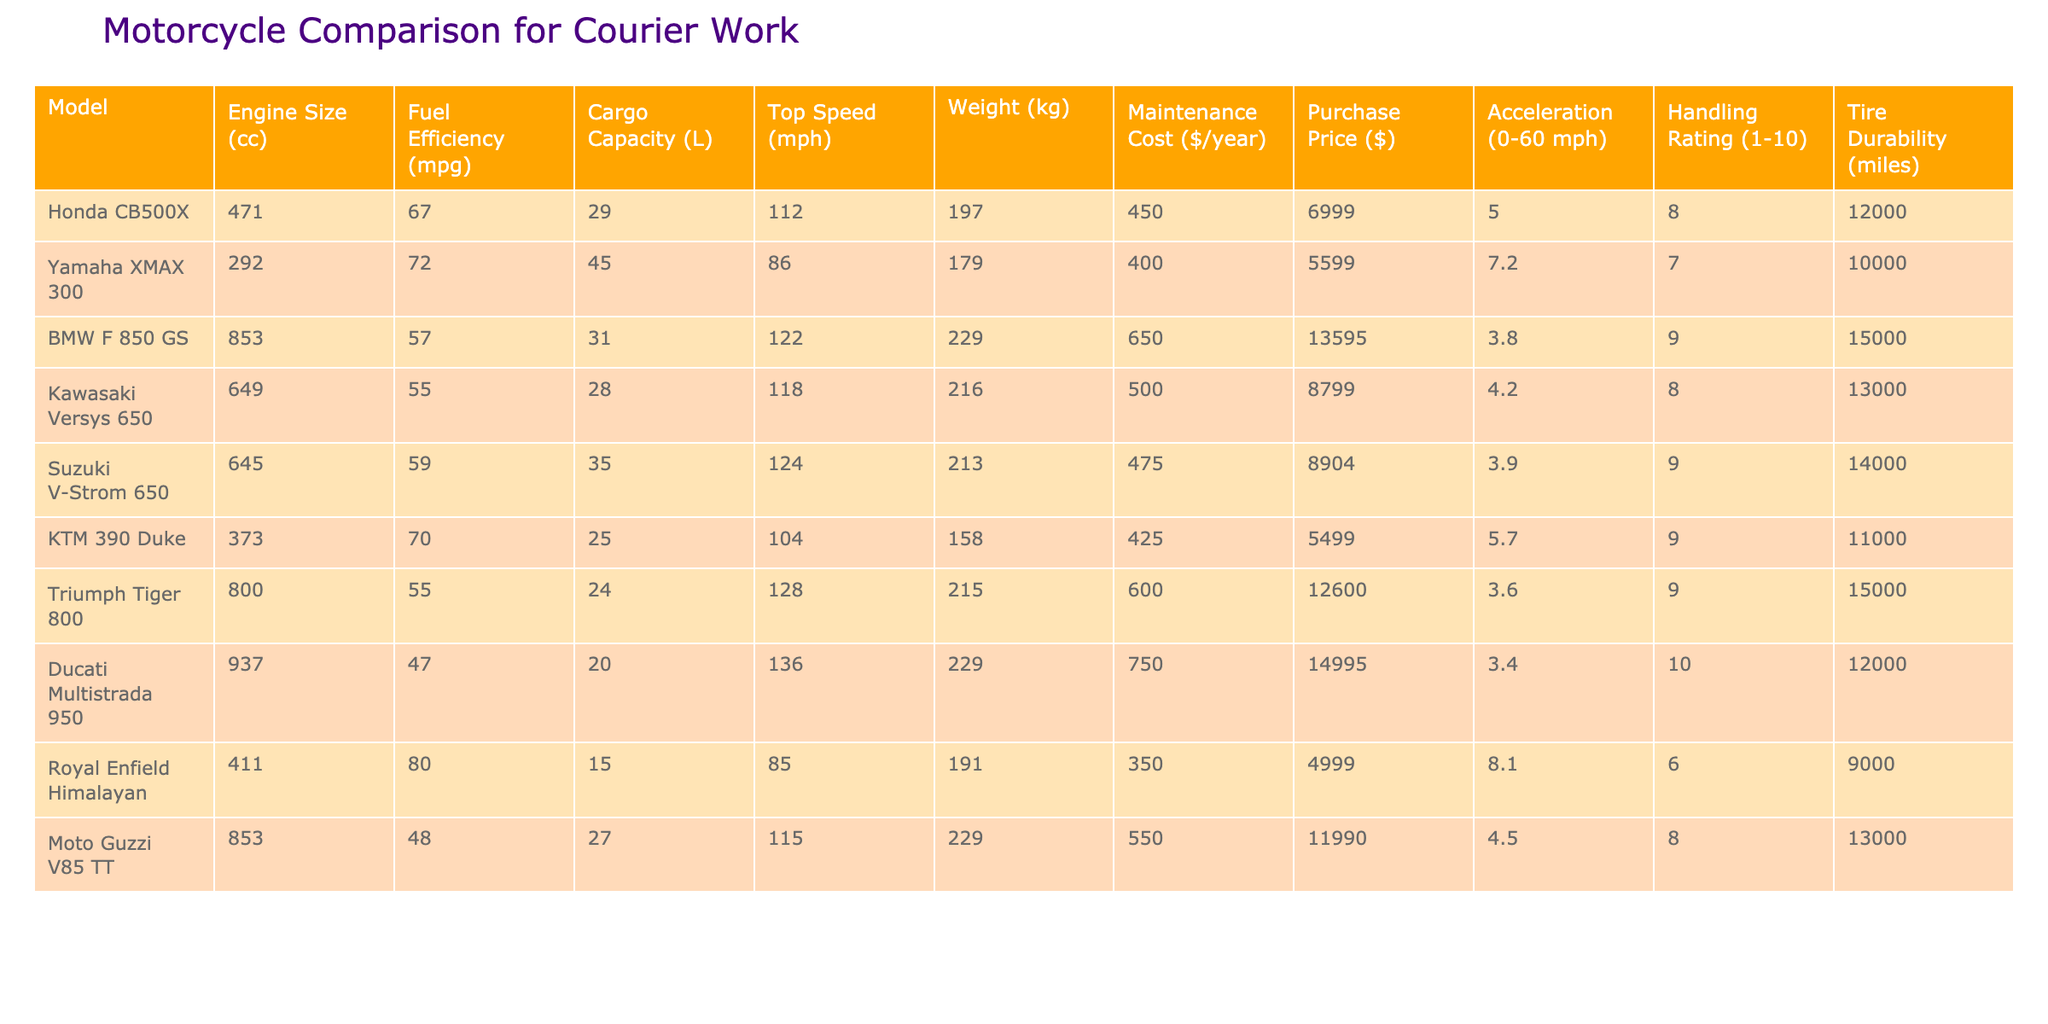What is the fuel efficiency of the Yamaha XMAX 300? The fuel efficiency of the Yamaha XMAX 300 is directly stated in the table, listed under the "Fuel Efficiency (mpg)" column. The corresponding value for this model is 72.
Answer: 72 Which motorcycle model has the highest cargo capacity? To answer this, we look at the "Cargo Capacity (L)" column and compare all the values. The maximum value is found under the Yamaha XMAX 300, which has a cargo capacity of 45 liters.
Answer: Yamaha XMAX 300 What is the average engine size of the motorcycles listed? We calculate the average by summing all engine sizes: (471 + 292 + 853 + 649 + 645 + 373 + 800 + 937 + 411 + 853) = 5798, and then dividing by the number of models (10). So, the average engine size is 579.8 cc.
Answer: 579.8 Is the Ducati Multistrada 950 more expensive than the BMW F 850 GS? We compare the "Purchase Price ($)" values for both models. The Ducati Multistrada 950 is priced at 14995, while the BMW F 850 GS is priced at 13595. Since 14995 is greater than 13595, the statement is true.
Answer: Yes Which motorcycle has the best handling rating and what is that rating? The "Handling Rating (1-10)" column indicates the handling scores of each motorcycle. The highest rating is found with the Ducati Multistrada 950, which has a handling rating of 10.
Answer: Ducati Multistrada 950, 10 What is the total weight of the top three heaviest motorcycles in the list? We identify the weights from the "Weight (kg)" column. The three heaviest motorcycles are the BMW F 850 GS (229 kg), Ducati Multistrada 950 (229 kg), and the Triumph Tiger 800 (215 kg). Thus, their total weight is 229 + 229 + 215 = 673 kg.
Answer: 673 kg Does the Kawasaki Versys 650 have better fuel efficiency than the Suzuki V-Strom 650? To answer this, we compare their "Fuel Efficiency (mpg)" values. The Kawasaki Versys 650 has an efficiency of 55 mpg, while the Suzuki V-Strom 650 has 59 mpg. Since 55 is less than 59, the statement is false.
Answer: No Which model has the best acceleration from 0 to 60 mph, and what is that time? We look at the "Acceleration (0-60 mph)" column and find that the Yamaha XMAX 300 has the best acceleration time at 7.2 seconds.
Answer: Yamaha XMAX 300, 7.2 seconds 